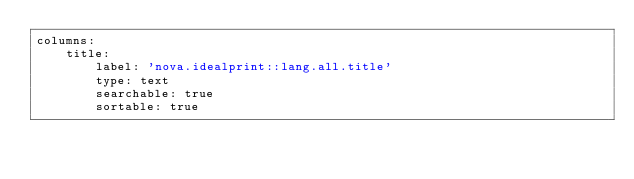<code> <loc_0><loc_0><loc_500><loc_500><_YAML_>columns:
    title:
        label: 'nova.idealprint::lang.all.title'
        type: text
        searchable: true
        sortable: true
</code> 